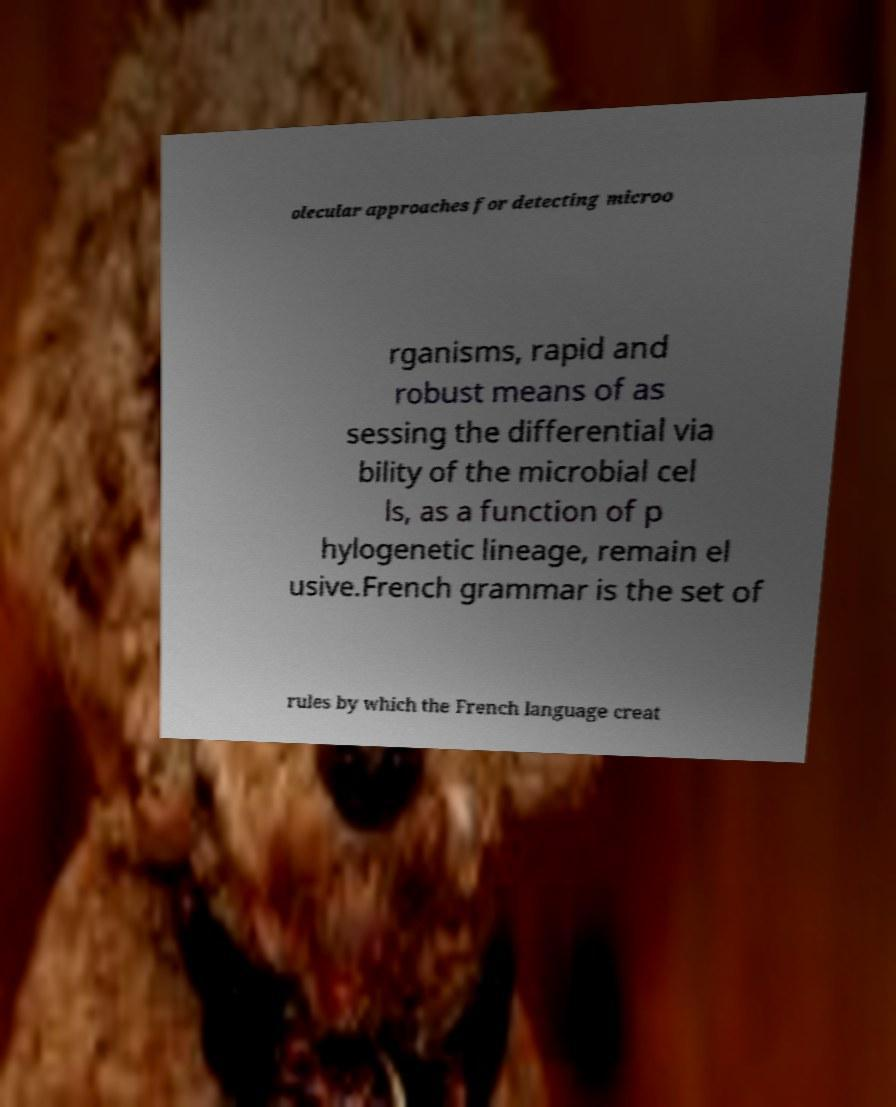I need the written content from this picture converted into text. Can you do that? olecular approaches for detecting microo rganisms, rapid and robust means of as sessing the differential via bility of the microbial cel ls, as a function of p hylogenetic lineage, remain el usive.French grammar is the set of rules by which the French language creat 